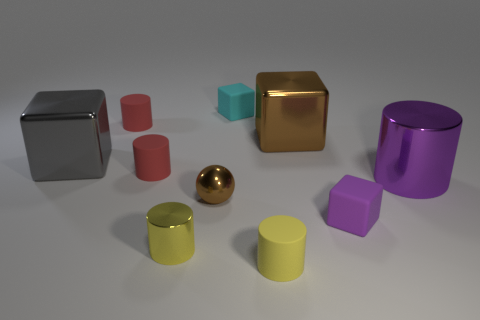What color is the tiny object that is made of the same material as the small ball?
Make the answer very short. Yellow. Are there more big purple cylinders than red rubber cylinders?
Offer a very short reply. No. Is the material of the small purple object the same as the large brown block?
Offer a very short reply. No. There is a tiny thing that is made of the same material as the brown sphere; what is its shape?
Your answer should be compact. Cylinder. Is the number of small yellow things less than the number of cylinders?
Your answer should be very brief. Yes. The tiny thing that is right of the tiny yellow metallic cylinder and left of the cyan object is made of what material?
Your response must be concise. Metal. There is a thing that is on the right side of the small rubber cube that is to the right of the small matte block that is behind the tiny purple object; what is its size?
Provide a succinct answer. Large. There is a tiny cyan rubber object; is its shape the same as the purple thing that is in front of the small brown thing?
Your answer should be compact. Yes. What number of metal objects are to the left of the large metal cylinder and behind the tiny sphere?
Give a very brief answer. 2. How many brown objects are metal balls or small cylinders?
Provide a short and direct response. 1. 